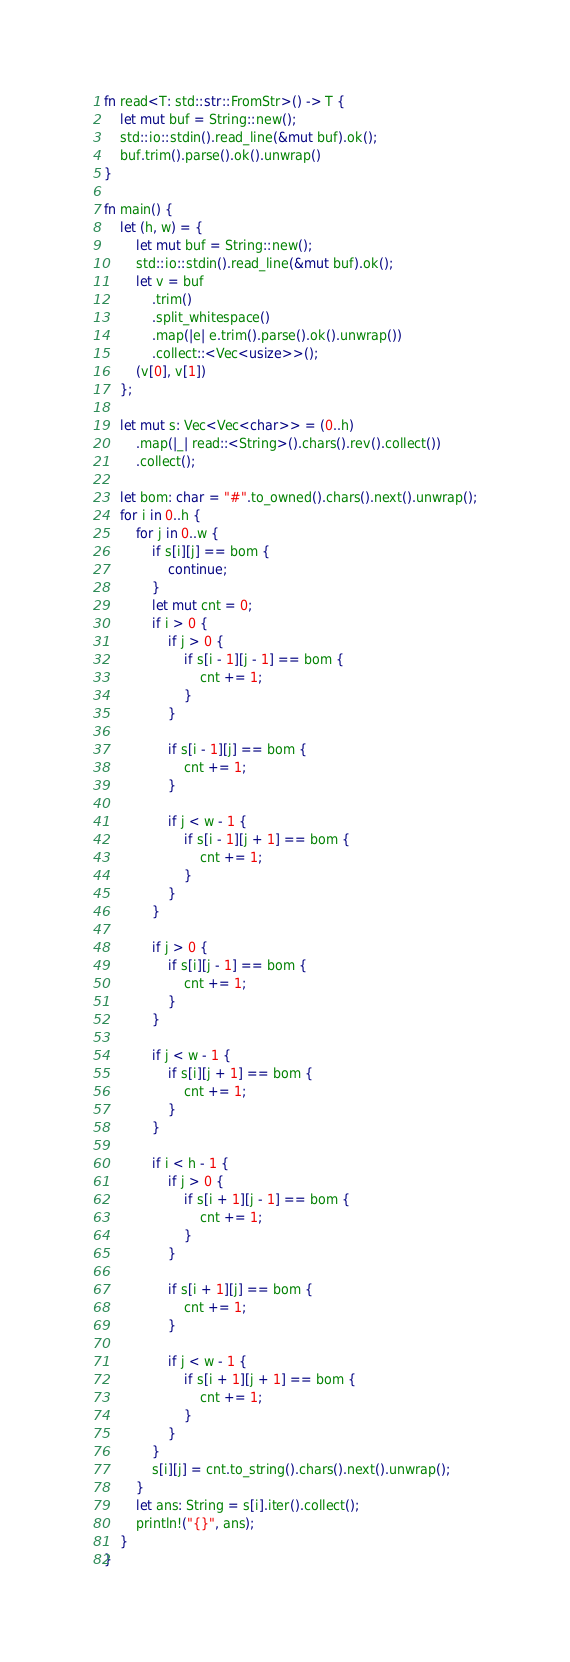<code> <loc_0><loc_0><loc_500><loc_500><_Rust_>fn read<T: std::str::FromStr>() -> T {
    let mut buf = String::new();
    std::io::stdin().read_line(&mut buf).ok();
    buf.trim().parse().ok().unwrap()
}

fn main() {
    let (h, w) = {
        let mut buf = String::new();
        std::io::stdin().read_line(&mut buf).ok();
        let v = buf
            .trim()
            .split_whitespace()
            .map(|e| e.trim().parse().ok().unwrap())
            .collect::<Vec<usize>>();
        (v[0], v[1])
    };

    let mut s: Vec<Vec<char>> = (0..h)
        .map(|_| read::<String>().chars().rev().collect())
        .collect();

    let bom: char = "#".to_owned().chars().next().unwrap();
    for i in 0..h {
        for j in 0..w {
            if s[i][j] == bom {
                continue;
            }
            let mut cnt = 0;
            if i > 0 {
                if j > 0 {
                    if s[i - 1][j - 1] == bom {
                        cnt += 1;
                    }
                }

                if s[i - 1][j] == bom {
                    cnt += 1;
                }

                if j < w - 1 {
                    if s[i - 1][j + 1] == bom {
                        cnt += 1;
                    }
                }
            }

            if j > 0 {
                if s[i][j - 1] == bom {
                    cnt += 1;
                }
            }

            if j < w - 1 {
                if s[i][j + 1] == bom {
                    cnt += 1;
                }
            }

            if i < h - 1 {
                if j > 0 {
                    if s[i + 1][j - 1] == bom {
                        cnt += 1;
                    }
                }

                if s[i + 1][j] == bom {
                    cnt += 1;
                }

                if j < w - 1 {
                    if s[i + 1][j + 1] == bom {
                        cnt += 1;
                    }
                }
            }
            s[i][j] = cnt.to_string().chars().next().unwrap();
        }
        let ans: String = s[i].iter().collect();
        println!("{}", ans);
    }
}
</code> 